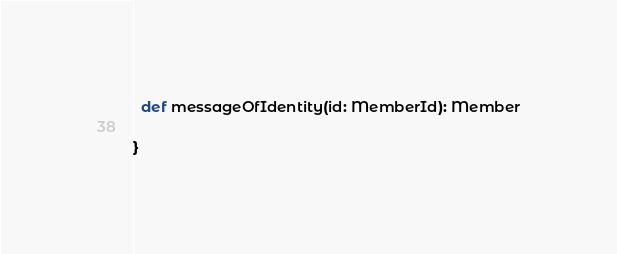Convert code to text. <code><loc_0><loc_0><loc_500><loc_500><_Scala_>  def messageOfIdentity(id: MemberId): Member

}
</code> 